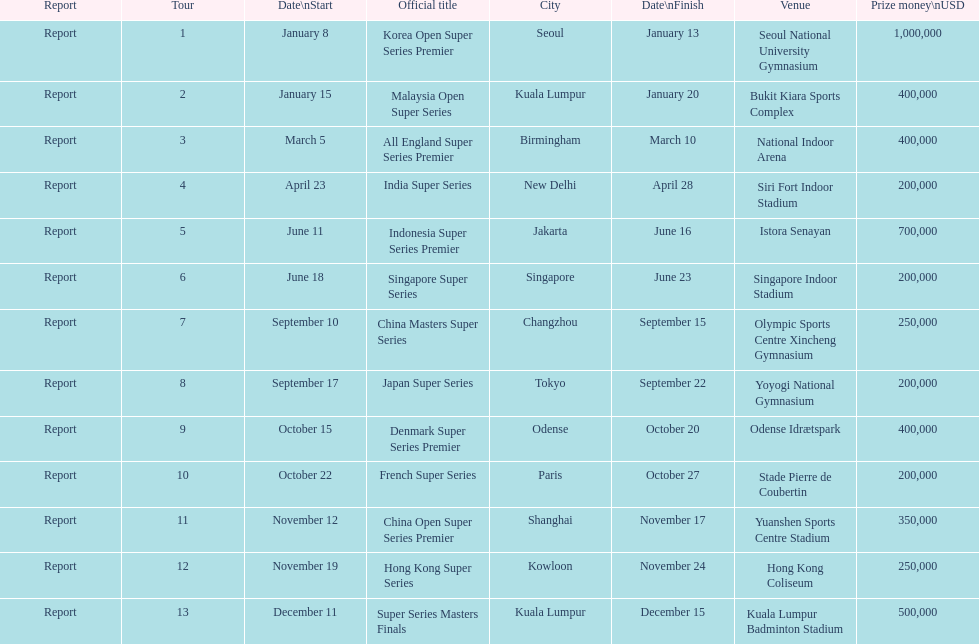What is the total prize payout for all 13 series? 5050000. 